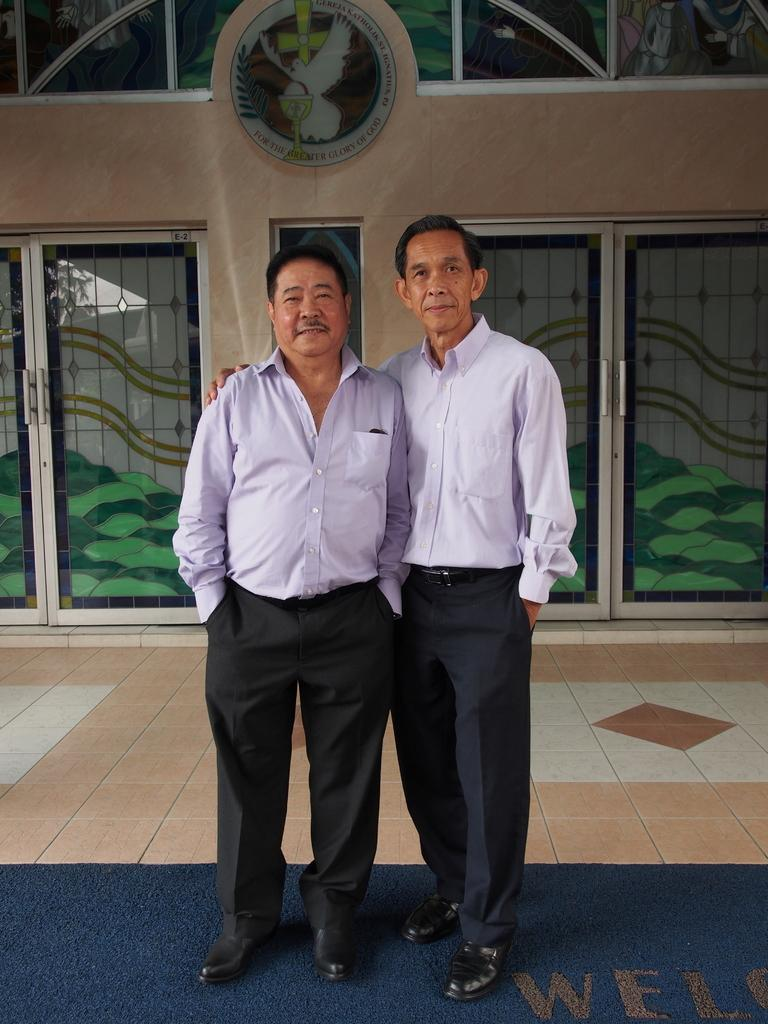How many people are in the image? There are two men standing in the image. What is on the floor in the image? There is a mat on the floor in the image. What can be seen on the wall in the background of the image? There is a board on a wall in the background of the image. What type of doors are visible in the background of the image? There are glass doors in the background of the image. What is depicted on the glass doors? There is a painting visible on the glass doors. Where are the chickens located in the image? There are no chickens present in the image. How many houses can be seen in the image? There are no houses visible in the image. 